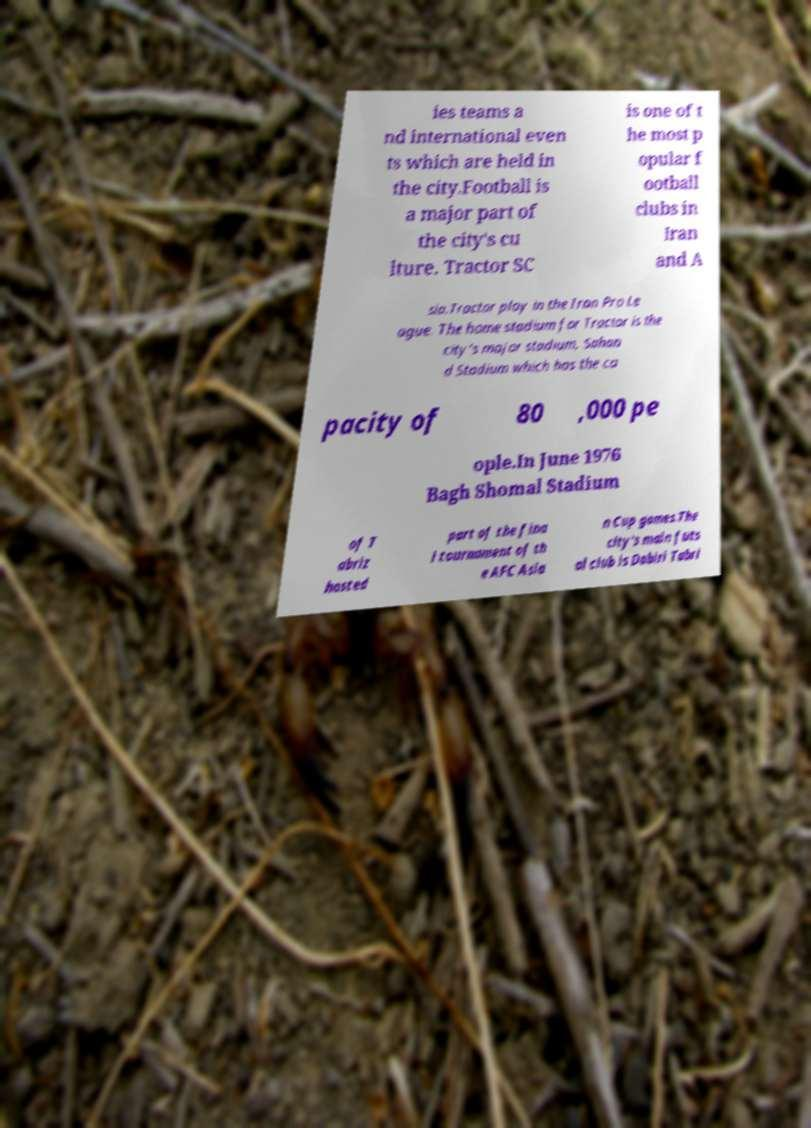There's text embedded in this image that I need extracted. Can you transcribe it verbatim? ies teams a nd international even ts which are held in the city.Football is a major part of the city's cu lture. Tractor SC is one of t he most p opular f ootball clubs in Iran and A sia.Tractor play in the Iran Pro Le ague. The home stadium for Tractor is the city's major stadium, Sahan d Stadium which has the ca pacity of 80 ,000 pe ople.In June 1976 Bagh Shomal Stadium of T abriz hosted part of the fina l tournament of th e AFC Asia n Cup games.The city's main futs al club is Dabiri Tabri 